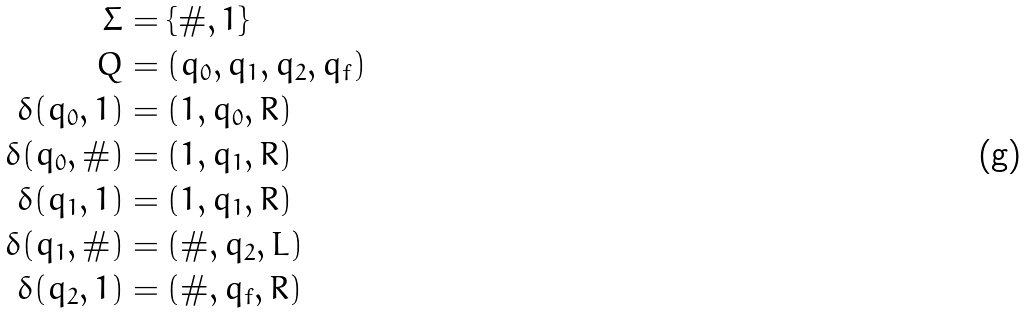Convert formula to latex. <formula><loc_0><loc_0><loc_500><loc_500>\Sigma & = \{ \# , 1 \} \\ Q & = ( q _ { 0 } , q _ { 1 } , q _ { 2 } , q _ { f } ) \\ \delta ( q _ { 0 } , 1 ) & = ( 1 , q _ { 0 } , R ) \\ \delta ( q _ { 0 } , \# ) & = ( 1 , q _ { 1 } , R ) \\ \delta ( q _ { 1 } , 1 ) & = ( 1 , q _ { 1 } , R ) \\ \delta ( q _ { 1 } , \# ) & = ( \# , q _ { 2 } , L ) \\ \delta ( q _ { 2 } , 1 ) & = ( \# , q _ { f } , R )</formula> 